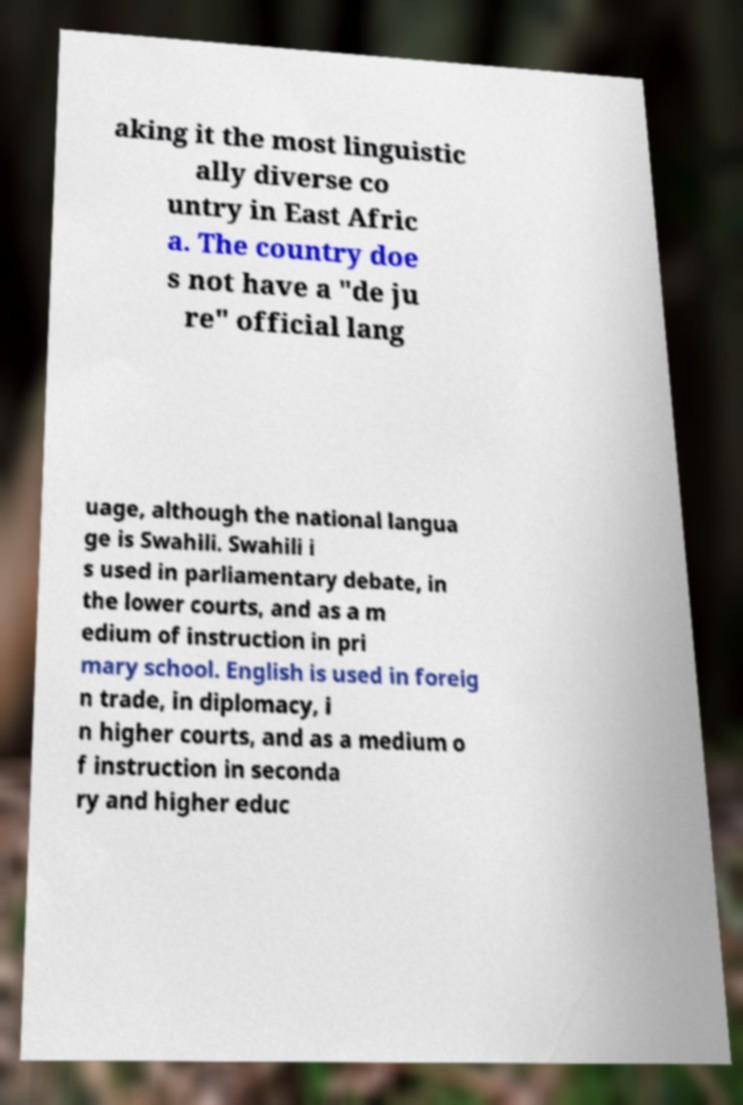There's text embedded in this image that I need extracted. Can you transcribe it verbatim? aking it the most linguistic ally diverse co untry in East Afric a. The country doe s not have a "de ju re" official lang uage, although the national langua ge is Swahili. Swahili i s used in parliamentary debate, in the lower courts, and as a m edium of instruction in pri mary school. English is used in foreig n trade, in diplomacy, i n higher courts, and as a medium o f instruction in seconda ry and higher educ 